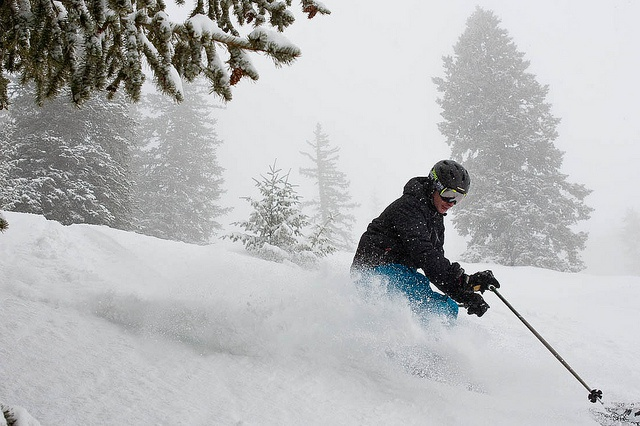Describe the objects in this image and their specific colors. I can see people in black, gray, darkgray, and blue tones in this image. 